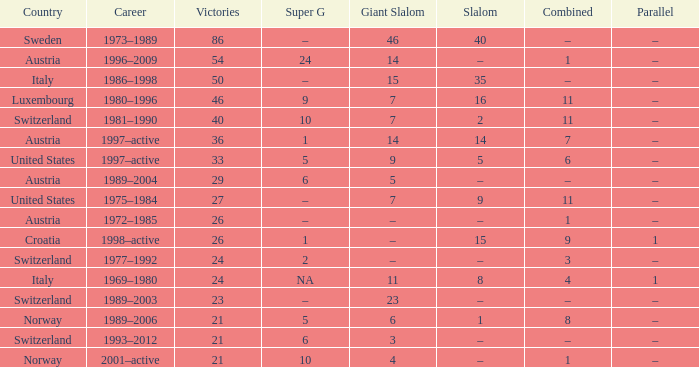Which profession features a parallel of –, a combined of –, and a giant slalom of 5? 1989–2004. 